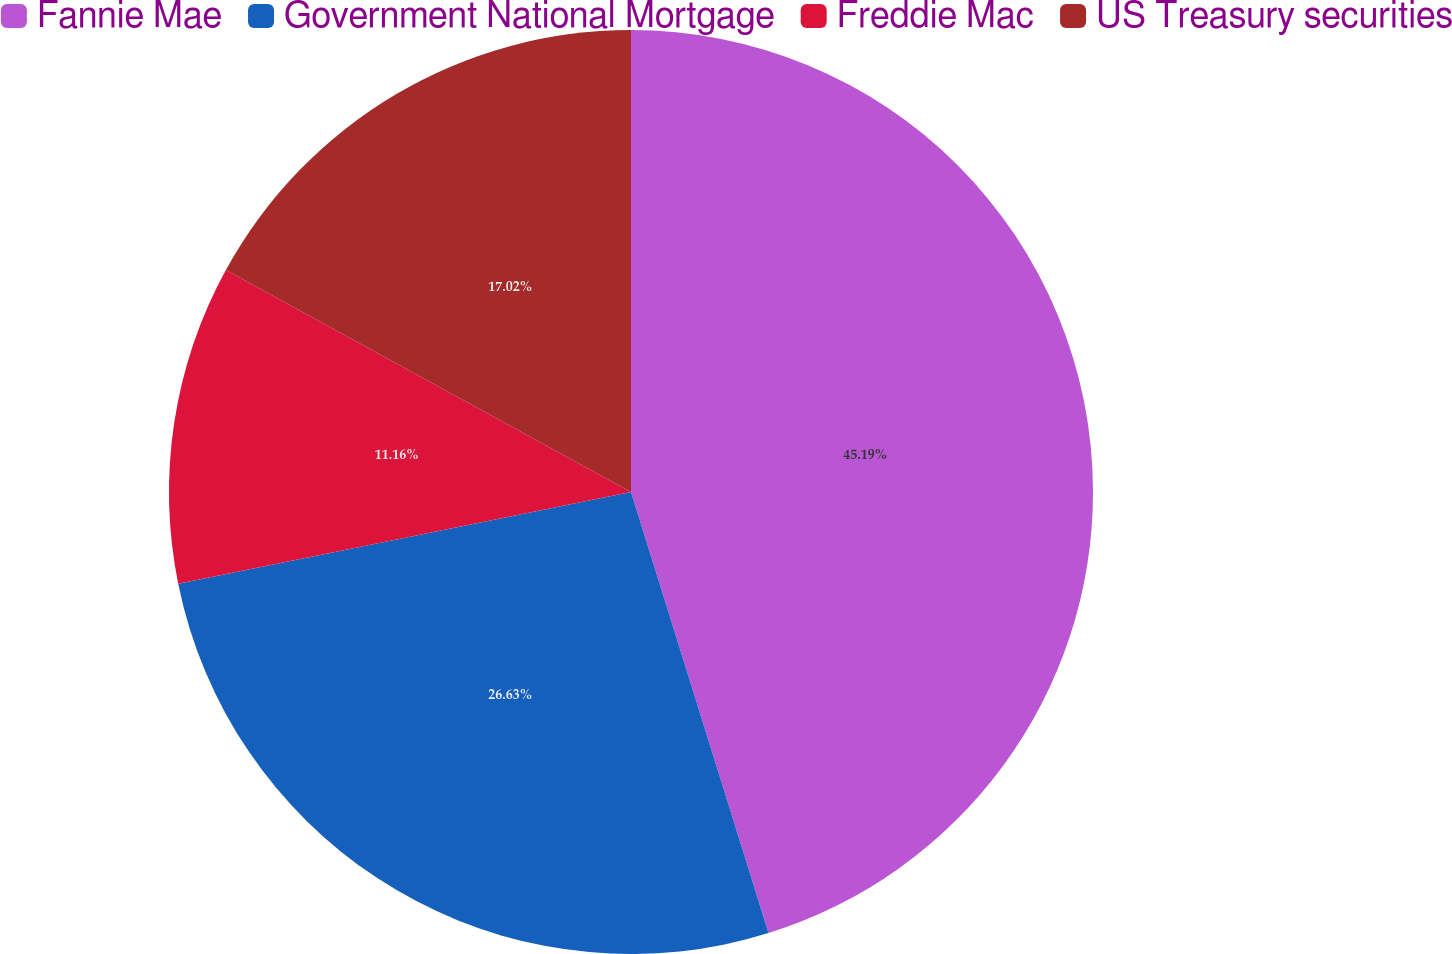<chart> <loc_0><loc_0><loc_500><loc_500><pie_chart><fcel>Fannie Mae<fcel>Government National Mortgage<fcel>Freddie Mac<fcel>US Treasury securities<nl><fcel>45.19%<fcel>26.63%<fcel>11.16%<fcel>17.02%<nl></chart> 